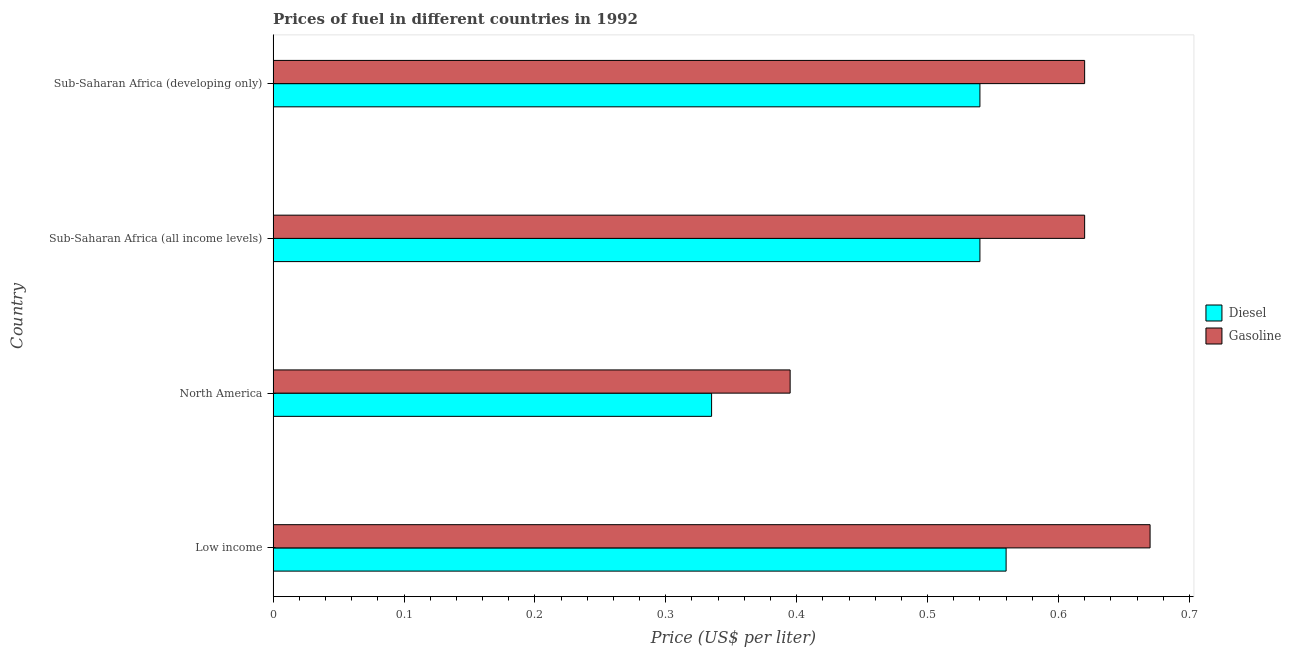How many different coloured bars are there?
Offer a very short reply. 2. Are the number of bars per tick equal to the number of legend labels?
Keep it short and to the point. Yes. How many bars are there on the 4th tick from the bottom?
Ensure brevity in your answer.  2. What is the label of the 3rd group of bars from the top?
Your answer should be very brief. North America. In how many cases, is the number of bars for a given country not equal to the number of legend labels?
Provide a short and direct response. 0. What is the gasoline price in Sub-Saharan Africa (all income levels)?
Your response must be concise. 0.62. Across all countries, what is the maximum diesel price?
Make the answer very short. 0.56. Across all countries, what is the minimum diesel price?
Provide a short and direct response. 0.34. In which country was the diesel price minimum?
Offer a terse response. North America. What is the total gasoline price in the graph?
Offer a very short reply. 2.31. What is the difference between the gasoline price in Low income and that in Sub-Saharan Africa (all income levels)?
Give a very brief answer. 0.05. What is the difference between the diesel price in Sub-Saharan Africa (all income levels) and the gasoline price in North America?
Make the answer very short. 0.15. What is the average gasoline price per country?
Give a very brief answer. 0.58. In how many countries, is the gasoline price greater than 0.54 US$ per litre?
Your answer should be very brief. 3. What is the ratio of the gasoline price in Low income to that in North America?
Offer a very short reply. 1.7. Is the diesel price in Low income less than that in Sub-Saharan Africa (all income levels)?
Your answer should be very brief. No. Is the difference between the gasoline price in North America and Sub-Saharan Africa (developing only) greater than the difference between the diesel price in North America and Sub-Saharan Africa (developing only)?
Give a very brief answer. No. What is the difference between the highest and the second highest diesel price?
Make the answer very short. 0.02. What is the difference between the highest and the lowest gasoline price?
Your answer should be very brief. 0.28. In how many countries, is the gasoline price greater than the average gasoline price taken over all countries?
Your answer should be very brief. 3. What does the 2nd bar from the top in Sub-Saharan Africa (all income levels) represents?
Ensure brevity in your answer.  Diesel. What does the 1st bar from the bottom in Sub-Saharan Africa (developing only) represents?
Keep it short and to the point. Diesel. Are all the bars in the graph horizontal?
Keep it short and to the point. Yes. Does the graph contain grids?
Your answer should be very brief. No. How many legend labels are there?
Your answer should be very brief. 2. How are the legend labels stacked?
Keep it short and to the point. Vertical. What is the title of the graph?
Offer a terse response. Prices of fuel in different countries in 1992. What is the label or title of the X-axis?
Make the answer very short. Price (US$ per liter). What is the label or title of the Y-axis?
Provide a short and direct response. Country. What is the Price (US$ per liter) in Diesel in Low income?
Your response must be concise. 0.56. What is the Price (US$ per liter) in Gasoline in Low income?
Provide a short and direct response. 0.67. What is the Price (US$ per liter) of Diesel in North America?
Provide a succinct answer. 0.34. What is the Price (US$ per liter) of Gasoline in North America?
Ensure brevity in your answer.  0.4. What is the Price (US$ per liter) in Diesel in Sub-Saharan Africa (all income levels)?
Offer a very short reply. 0.54. What is the Price (US$ per liter) of Gasoline in Sub-Saharan Africa (all income levels)?
Provide a succinct answer. 0.62. What is the Price (US$ per liter) in Diesel in Sub-Saharan Africa (developing only)?
Keep it short and to the point. 0.54. What is the Price (US$ per liter) of Gasoline in Sub-Saharan Africa (developing only)?
Provide a short and direct response. 0.62. Across all countries, what is the maximum Price (US$ per liter) of Diesel?
Provide a succinct answer. 0.56. Across all countries, what is the maximum Price (US$ per liter) of Gasoline?
Your answer should be very brief. 0.67. Across all countries, what is the minimum Price (US$ per liter) in Diesel?
Provide a short and direct response. 0.34. Across all countries, what is the minimum Price (US$ per liter) of Gasoline?
Give a very brief answer. 0.4. What is the total Price (US$ per liter) of Diesel in the graph?
Make the answer very short. 1.98. What is the total Price (US$ per liter) of Gasoline in the graph?
Make the answer very short. 2.31. What is the difference between the Price (US$ per liter) of Diesel in Low income and that in North America?
Make the answer very short. 0.23. What is the difference between the Price (US$ per liter) of Gasoline in Low income and that in North America?
Make the answer very short. 0.28. What is the difference between the Price (US$ per liter) of Diesel in Low income and that in Sub-Saharan Africa (all income levels)?
Make the answer very short. 0.02. What is the difference between the Price (US$ per liter) in Gasoline in Low income and that in Sub-Saharan Africa (developing only)?
Ensure brevity in your answer.  0.05. What is the difference between the Price (US$ per liter) in Diesel in North America and that in Sub-Saharan Africa (all income levels)?
Give a very brief answer. -0.2. What is the difference between the Price (US$ per liter) in Gasoline in North America and that in Sub-Saharan Africa (all income levels)?
Make the answer very short. -0.23. What is the difference between the Price (US$ per liter) in Diesel in North America and that in Sub-Saharan Africa (developing only)?
Provide a short and direct response. -0.2. What is the difference between the Price (US$ per liter) of Gasoline in North America and that in Sub-Saharan Africa (developing only)?
Provide a succinct answer. -0.23. What is the difference between the Price (US$ per liter) of Gasoline in Sub-Saharan Africa (all income levels) and that in Sub-Saharan Africa (developing only)?
Ensure brevity in your answer.  0. What is the difference between the Price (US$ per liter) of Diesel in Low income and the Price (US$ per liter) of Gasoline in North America?
Your answer should be very brief. 0.17. What is the difference between the Price (US$ per liter) of Diesel in Low income and the Price (US$ per liter) of Gasoline in Sub-Saharan Africa (all income levels)?
Keep it short and to the point. -0.06. What is the difference between the Price (US$ per liter) of Diesel in Low income and the Price (US$ per liter) of Gasoline in Sub-Saharan Africa (developing only)?
Make the answer very short. -0.06. What is the difference between the Price (US$ per liter) in Diesel in North America and the Price (US$ per liter) in Gasoline in Sub-Saharan Africa (all income levels)?
Your answer should be compact. -0.28. What is the difference between the Price (US$ per liter) in Diesel in North America and the Price (US$ per liter) in Gasoline in Sub-Saharan Africa (developing only)?
Provide a short and direct response. -0.28. What is the difference between the Price (US$ per liter) of Diesel in Sub-Saharan Africa (all income levels) and the Price (US$ per liter) of Gasoline in Sub-Saharan Africa (developing only)?
Keep it short and to the point. -0.08. What is the average Price (US$ per liter) in Diesel per country?
Your answer should be very brief. 0.49. What is the average Price (US$ per liter) of Gasoline per country?
Ensure brevity in your answer.  0.58. What is the difference between the Price (US$ per liter) of Diesel and Price (US$ per liter) of Gasoline in Low income?
Your answer should be very brief. -0.11. What is the difference between the Price (US$ per liter) in Diesel and Price (US$ per liter) in Gasoline in North America?
Offer a terse response. -0.06. What is the difference between the Price (US$ per liter) in Diesel and Price (US$ per liter) in Gasoline in Sub-Saharan Africa (all income levels)?
Give a very brief answer. -0.08. What is the difference between the Price (US$ per liter) of Diesel and Price (US$ per liter) of Gasoline in Sub-Saharan Africa (developing only)?
Offer a very short reply. -0.08. What is the ratio of the Price (US$ per liter) of Diesel in Low income to that in North America?
Keep it short and to the point. 1.67. What is the ratio of the Price (US$ per liter) in Gasoline in Low income to that in North America?
Offer a terse response. 1.7. What is the ratio of the Price (US$ per liter) in Gasoline in Low income to that in Sub-Saharan Africa (all income levels)?
Your response must be concise. 1.08. What is the ratio of the Price (US$ per liter) in Diesel in Low income to that in Sub-Saharan Africa (developing only)?
Ensure brevity in your answer.  1.04. What is the ratio of the Price (US$ per liter) of Gasoline in Low income to that in Sub-Saharan Africa (developing only)?
Make the answer very short. 1.08. What is the ratio of the Price (US$ per liter) of Diesel in North America to that in Sub-Saharan Africa (all income levels)?
Offer a terse response. 0.62. What is the ratio of the Price (US$ per liter) of Gasoline in North America to that in Sub-Saharan Africa (all income levels)?
Keep it short and to the point. 0.64. What is the ratio of the Price (US$ per liter) in Diesel in North America to that in Sub-Saharan Africa (developing only)?
Your answer should be very brief. 0.62. What is the ratio of the Price (US$ per liter) of Gasoline in North America to that in Sub-Saharan Africa (developing only)?
Make the answer very short. 0.64. What is the ratio of the Price (US$ per liter) in Diesel in Sub-Saharan Africa (all income levels) to that in Sub-Saharan Africa (developing only)?
Make the answer very short. 1. What is the difference between the highest and the second highest Price (US$ per liter) in Gasoline?
Your response must be concise. 0.05. What is the difference between the highest and the lowest Price (US$ per liter) in Diesel?
Your answer should be very brief. 0.23. What is the difference between the highest and the lowest Price (US$ per liter) of Gasoline?
Offer a terse response. 0.28. 